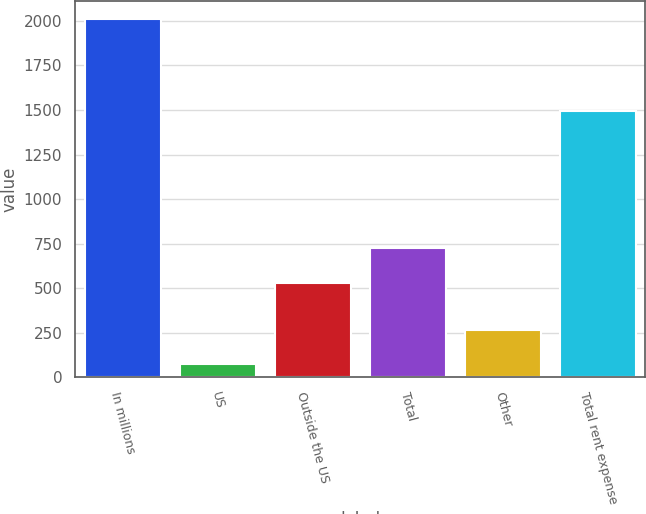Convert chart to OTSL. <chart><loc_0><loc_0><loc_500><loc_500><bar_chart><fcel>In millions<fcel>US<fcel>Outside the US<fcel>Total<fcel>Other<fcel>Total rent expense<nl><fcel>2008<fcel>73.7<fcel>532<fcel>725.43<fcel>267.13<fcel>1491.6<nl></chart> 